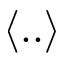Convert formula to latex. <formula><loc_0><loc_0><loc_500><loc_500>\langle . . \rangle</formula> 